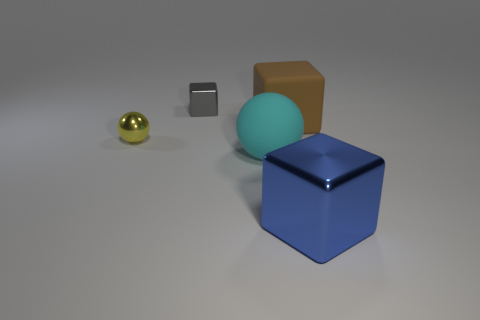How many gray shiny things are there?
Offer a very short reply. 1. What color is the ball behind the large cyan matte thing?
Make the answer very short. Yellow. How big is the brown rubber thing?
Give a very brief answer. Large. Does the big shiny cube have the same color as the cube to the left of the big cyan thing?
Make the answer very short. No. What color is the cube that is in front of the small object in front of the small cube?
Provide a short and direct response. Blue. Do the large blue shiny object that is on the right side of the tiny gray shiny thing and the small yellow thing have the same shape?
Offer a terse response. No. How many big blocks are both behind the rubber sphere and on the right side of the brown cube?
Offer a very short reply. 0. There is a metal cube that is on the left side of the metal cube in front of the metallic ball that is behind the large cyan sphere; what color is it?
Make the answer very short. Gray. What number of large things are to the right of the metallic thing that is in front of the large cyan matte object?
Your answer should be very brief. 0. How many other objects are there of the same shape as the tiny yellow object?
Ensure brevity in your answer.  1. 